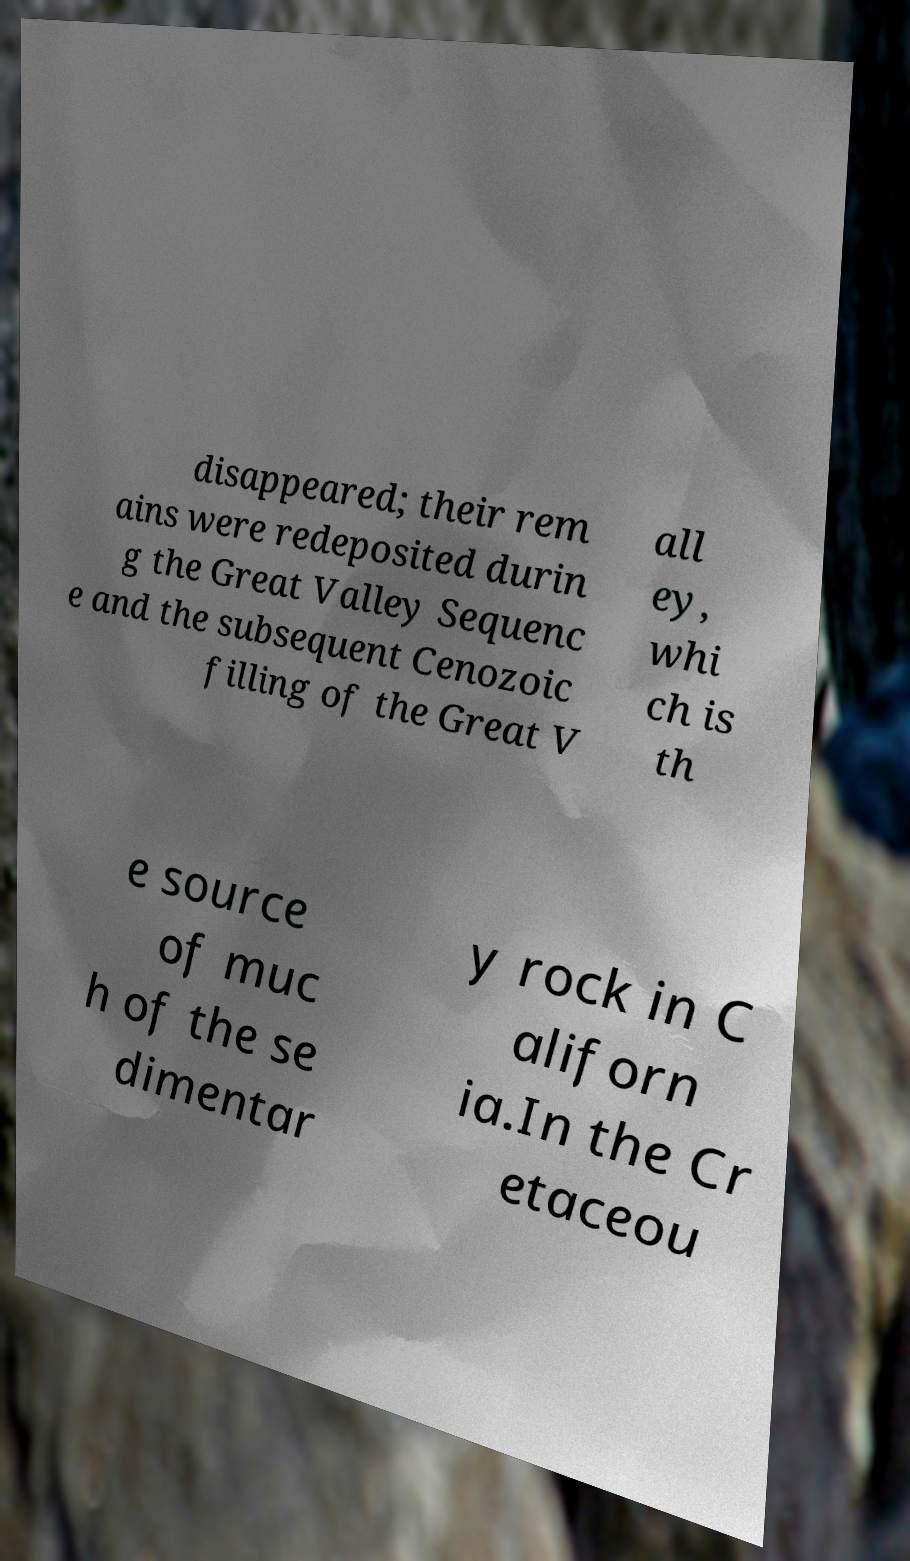Could you assist in decoding the text presented in this image and type it out clearly? disappeared; their rem ains were redeposited durin g the Great Valley Sequenc e and the subsequent Cenozoic filling of the Great V all ey, whi ch is th e source of muc h of the se dimentar y rock in C aliforn ia.In the Cr etaceou 